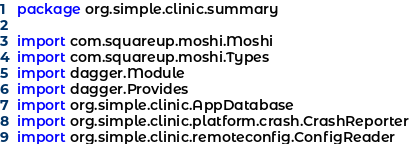Convert code to text. <code><loc_0><loc_0><loc_500><loc_500><_Kotlin_>package org.simple.clinic.summary

import com.squareup.moshi.Moshi
import com.squareup.moshi.Types
import dagger.Module
import dagger.Provides
import org.simple.clinic.AppDatabase
import org.simple.clinic.platform.crash.CrashReporter
import org.simple.clinic.remoteconfig.ConfigReader</code> 